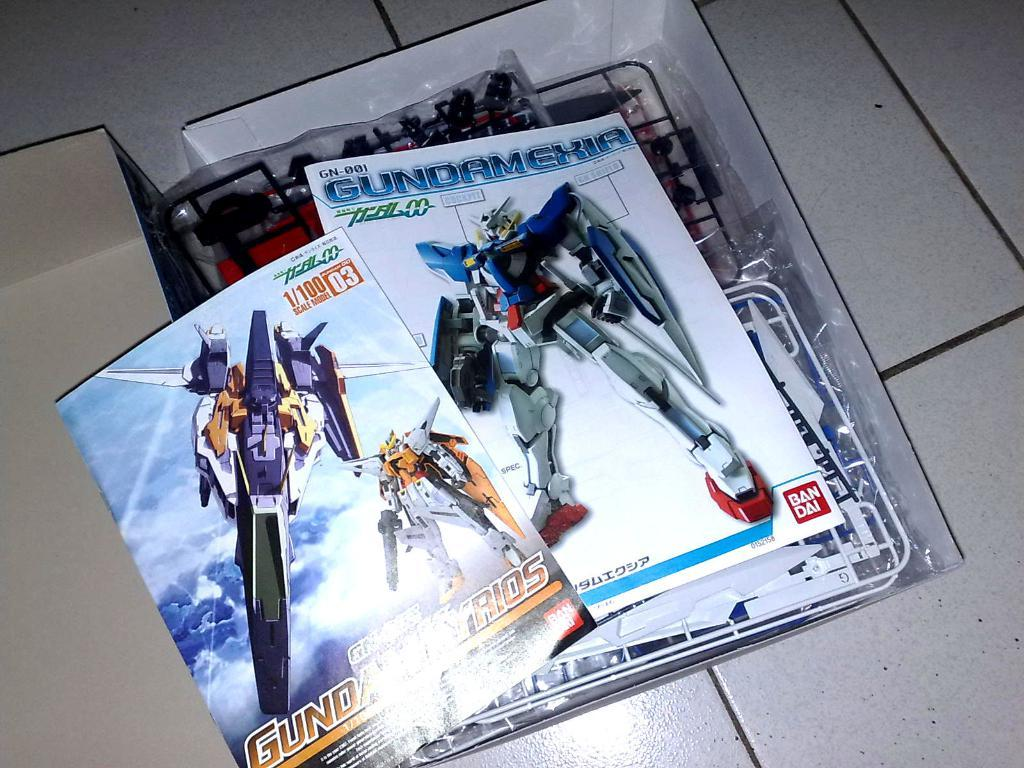What type of items can be seen in the image? There are books and objects in the image. Can you describe the boxes on the floor in the image? Yes, there are boxes on the floor in the image. How many cats are sitting on top of the books in the image? There are no cats present in the image. What type of lumber is being used to build the bookshelf in the image? There is no bookshelf or lumber visible in the image. 